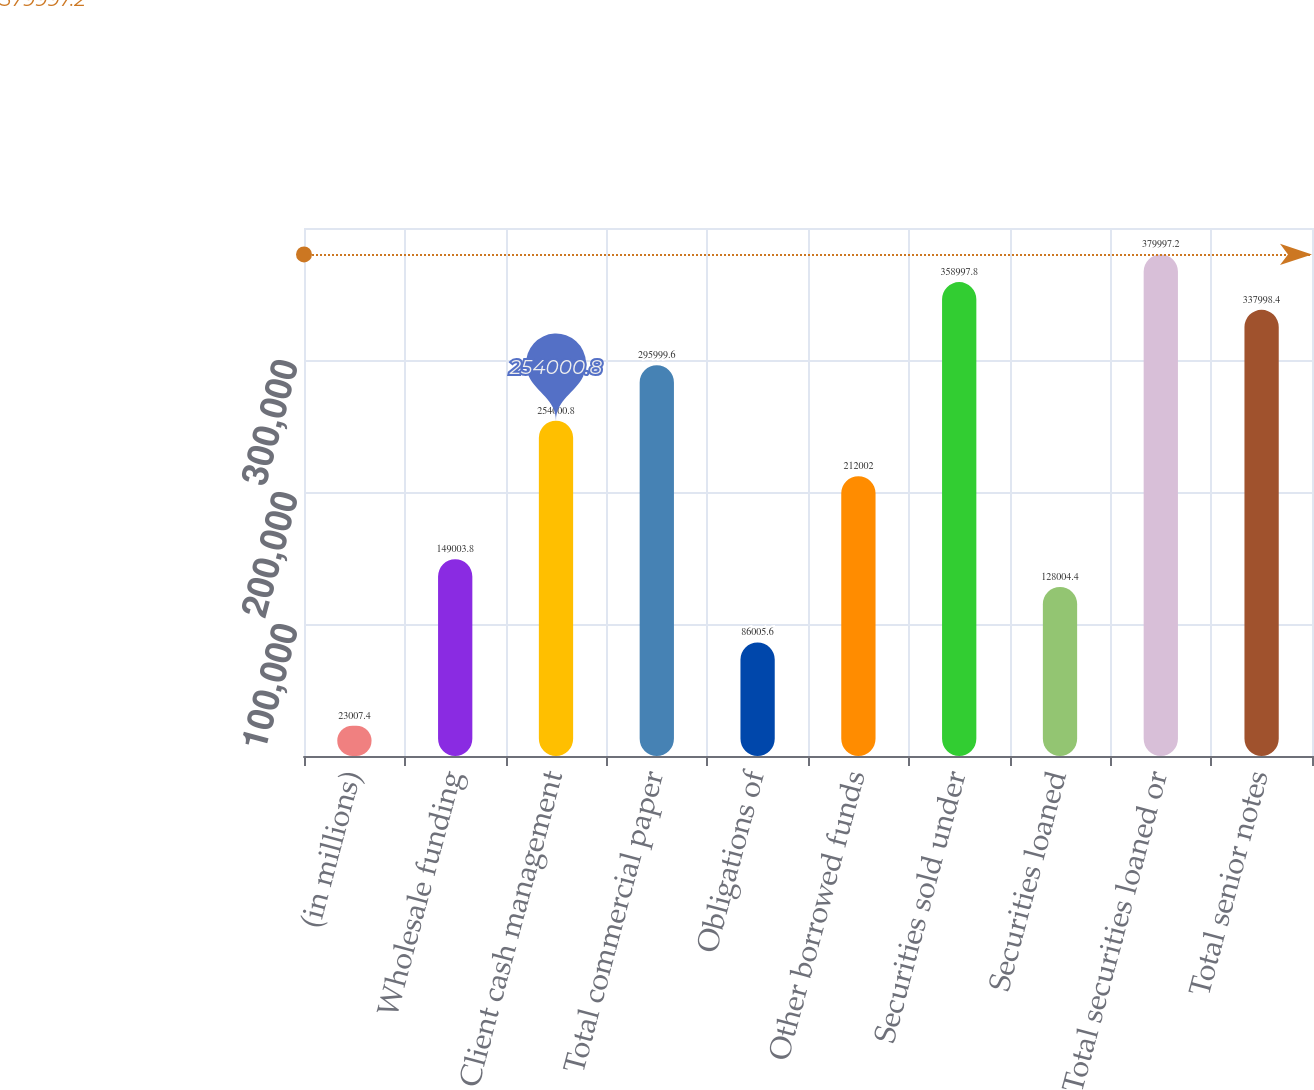Convert chart. <chart><loc_0><loc_0><loc_500><loc_500><bar_chart><fcel>(in millions)<fcel>Wholesale funding<fcel>Client cash management<fcel>Total commercial paper<fcel>Obligations of<fcel>Other borrowed funds<fcel>Securities sold under<fcel>Securities loaned<fcel>Total securities loaned or<fcel>Total senior notes<nl><fcel>23007.4<fcel>149004<fcel>254001<fcel>296000<fcel>86005.6<fcel>212002<fcel>358998<fcel>128004<fcel>379997<fcel>337998<nl></chart> 